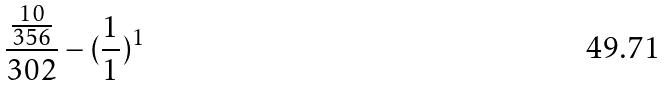<formula> <loc_0><loc_0><loc_500><loc_500>\frac { \frac { 1 0 } { 3 5 6 } } { 3 0 2 } - ( \frac { 1 } { 1 } ) ^ { 1 }</formula> 